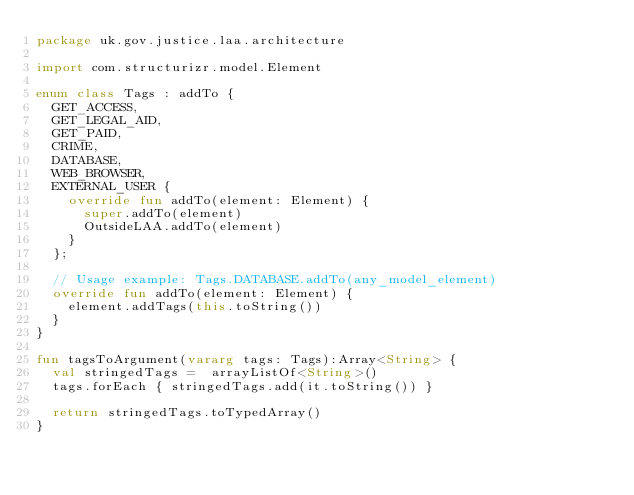Convert code to text. <code><loc_0><loc_0><loc_500><loc_500><_Kotlin_>package uk.gov.justice.laa.architecture

import com.structurizr.model.Element

enum class Tags : addTo {
  GET_ACCESS,
  GET_LEGAL_AID,
  GET_PAID,
  CRIME,
  DATABASE,
  WEB_BROWSER,
  EXTERNAL_USER {
    override fun addTo(element: Element) {
      super.addTo(element)
      OutsideLAA.addTo(element)
    }
  };

  // Usage example: Tags.DATABASE.addTo(any_model_element)
  override fun addTo(element: Element) {
    element.addTags(this.toString())
  }
}

fun tagsToArgument(vararg tags: Tags):Array<String> {
  val stringedTags =  arrayListOf<String>()
  tags.forEach { stringedTags.add(it.toString()) }

  return stringedTags.toTypedArray()
}
</code> 